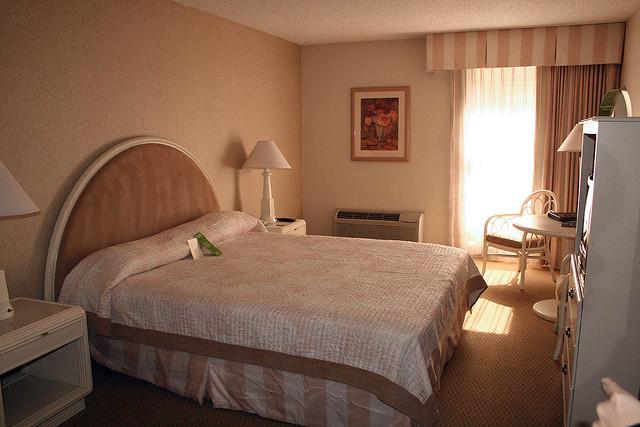Is it a sunny day?
Concise answer only. Yes. What color is the bedding?
Short answer required. White. Which room of the house is this?
Keep it brief. Bedroom. 